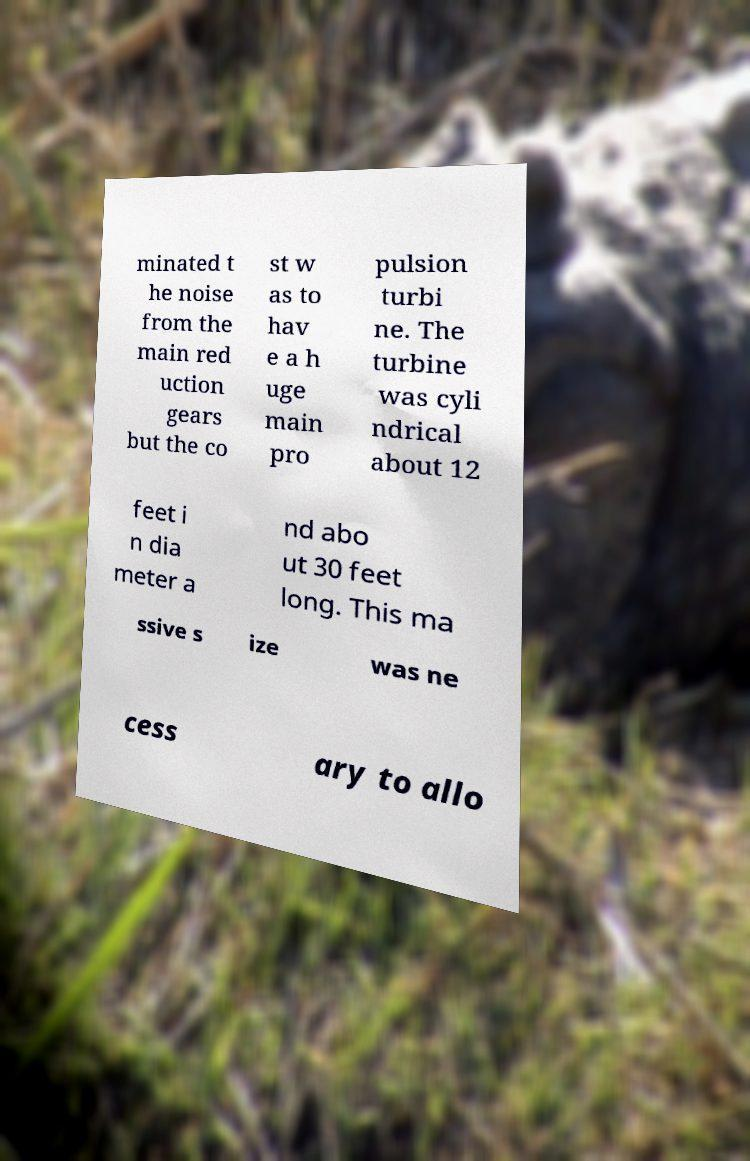Could you extract and type out the text from this image? minated t he noise from the main red uction gears but the co st w as to hav e a h uge main pro pulsion turbi ne. The turbine was cyli ndrical about 12 feet i n dia meter a nd abo ut 30 feet long. This ma ssive s ize was ne cess ary to allo 